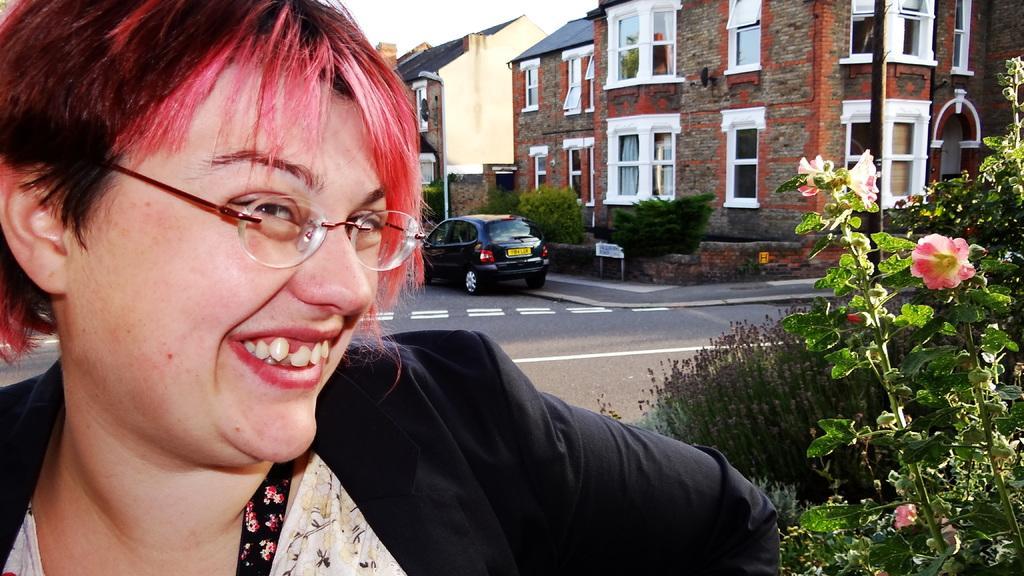Can you describe this image briefly? Here we can see a woman. She is smiling and she has spectacles. There is a car on the road. Here we can see plants, flowers, boards, poles, and buildings. 